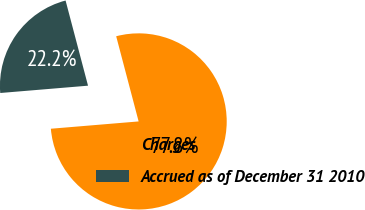Convert chart. <chart><loc_0><loc_0><loc_500><loc_500><pie_chart><fcel>Charges<fcel>Accrued as of December 31 2010<nl><fcel>77.78%<fcel>22.22%<nl></chart> 